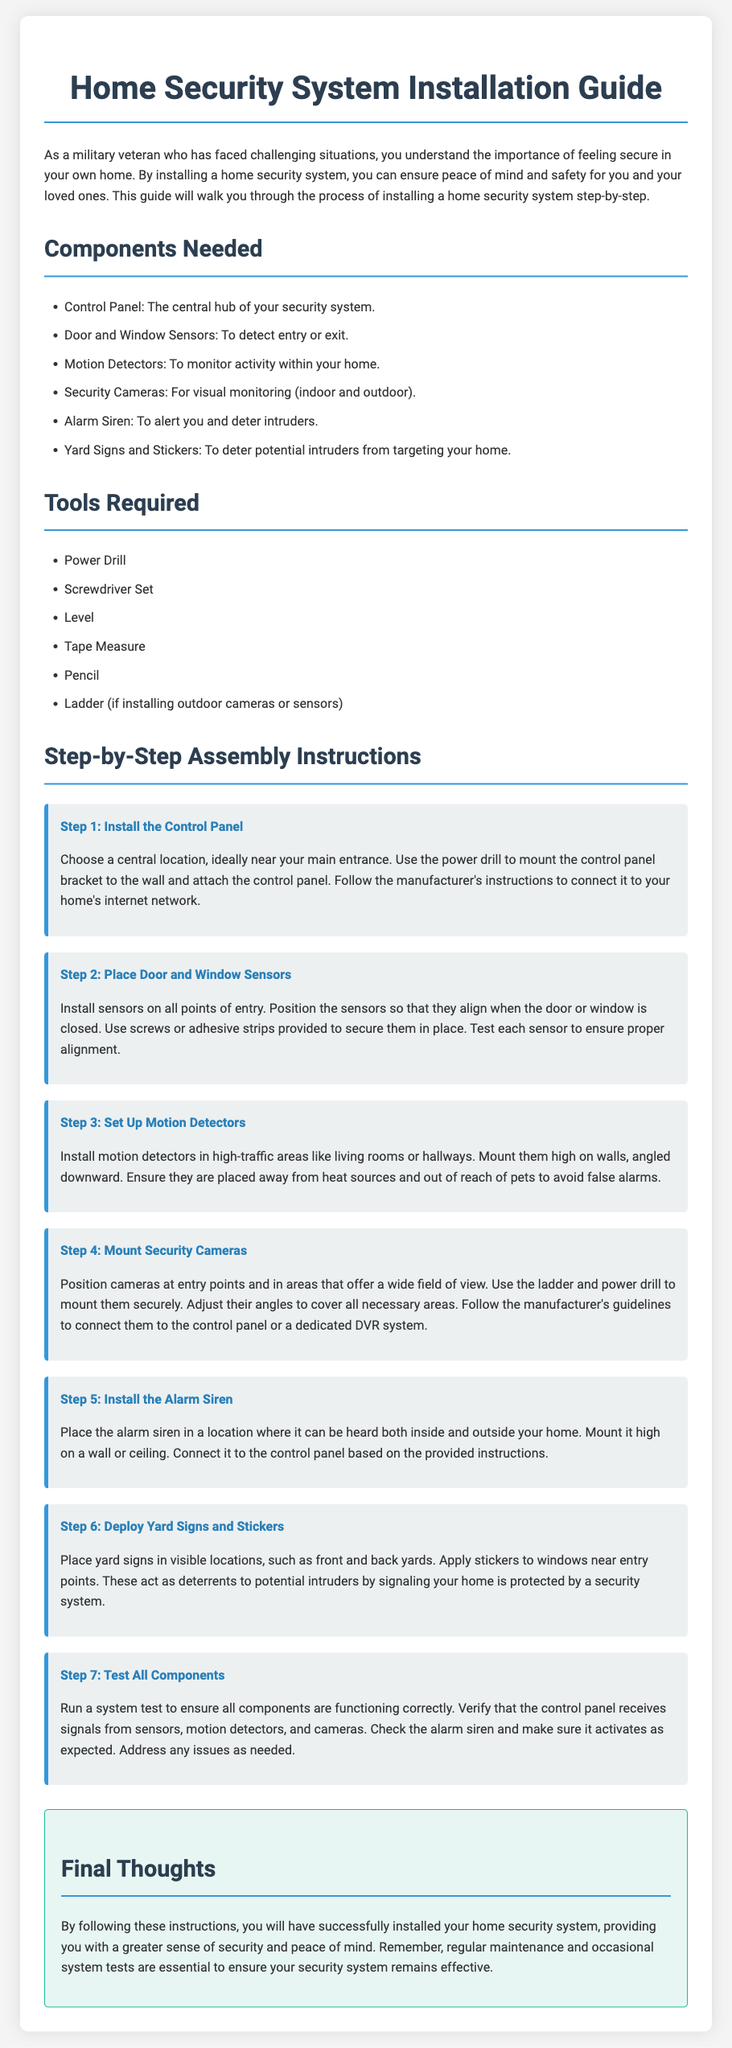What is the main purpose of the document? The document serves as a guide to help users install a home security system for peace of mind and safety.
Answer: Peace of mind and safety How many components are listed for the home security system? There are six components needed for the home security system according to the document.
Answer: Six What is the first step in the assembly instructions? The first step involves installing the control panel at a central location near the main entrance.
Answer: Install the Control Panel What tools are needed to install the system? The document lists six tools required for installation, including a power drill and screwdriver set.
Answer: Power Drill, Screwdriver Set Where should the motion detectors be placed? The motion detectors should be installed in high-traffic areas like living rooms or hallways, mounted high on walls.
Answer: High-traffic areas What is advised to be done after installation? After installation, the document advises running a system test to ensure everything functions correctly.
Answer: Test All Components What function do yard signs and stickers serve? They act as deterrents to potential intruders by signaling that the home is protected by a security system.
Answer: Deterrents Which component should be mounted high on a wall or ceiling? The alarm siren should be placed in a location where it can be heard and mounted high on a wall or ceiling.
Answer: Alarm Siren What is mentioned as essential for the ongoing effectiveness of the security system? Regular maintenance and occasional system tests are essential to ensure the security system remains effective.
Answer: Regular maintenance and tests 